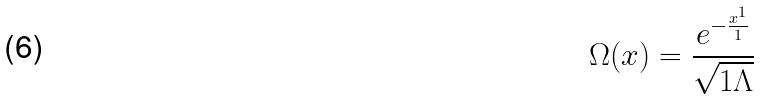<formula> <loc_0><loc_0><loc_500><loc_500>\Omega ( x ) = \frac { e ^ { - \frac { x ^ { 1 } } { 1 } } } { \sqrt { 1 \Lambda } }</formula> 